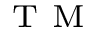<formula> <loc_0><loc_0><loc_500><loc_500>^ { T } M</formula> 